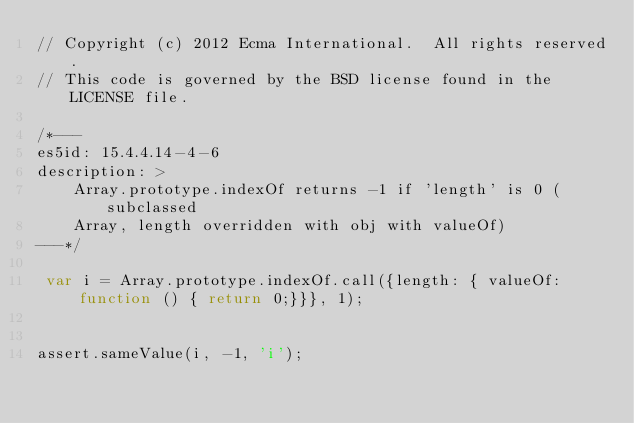Convert code to text. <code><loc_0><loc_0><loc_500><loc_500><_JavaScript_>// Copyright (c) 2012 Ecma International.  All rights reserved.
// This code is governed by the BSD license found in the LICENSE file.

/*---
es5id: 15.4.4.14-4-6
description: >
    Array.prototype.indexOf returns -1 if 'length' is 0 (subclassed
    Array, length overridden with obj with valueOf)
---*/

 var i = Array.prototype.indexOf.call({length: { valueOf: function () { return 0;}}}, 1);
  

assert.sameValue(i, -1, 'i');
</code> 